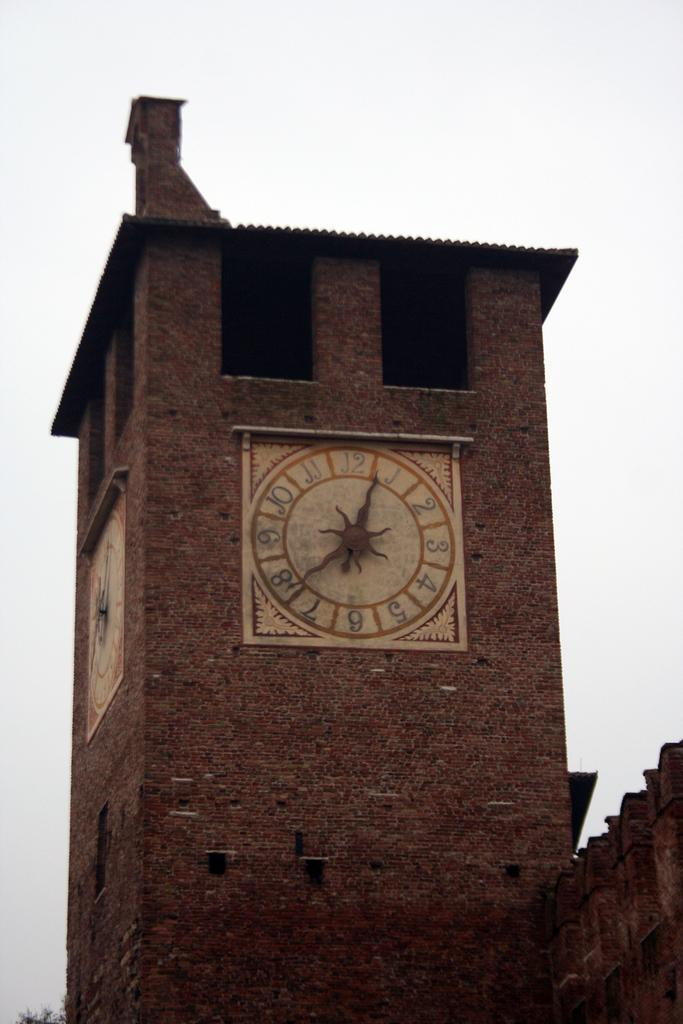<image>
Create a compact narrative representing the image presented. Large building with a clock that has the hands on number 1 and 8. 